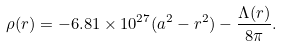<formula> <loc_0><loc_0><loc_500><loc_500>\rho ( r ) = - 6 . 8 1 \times 1 0 ^ { 2 7 } ( a ^ { 2 } - r ^ { 2 } ) - \frac { \Lambda ( r ) } { 8 \pi } .</formula> 